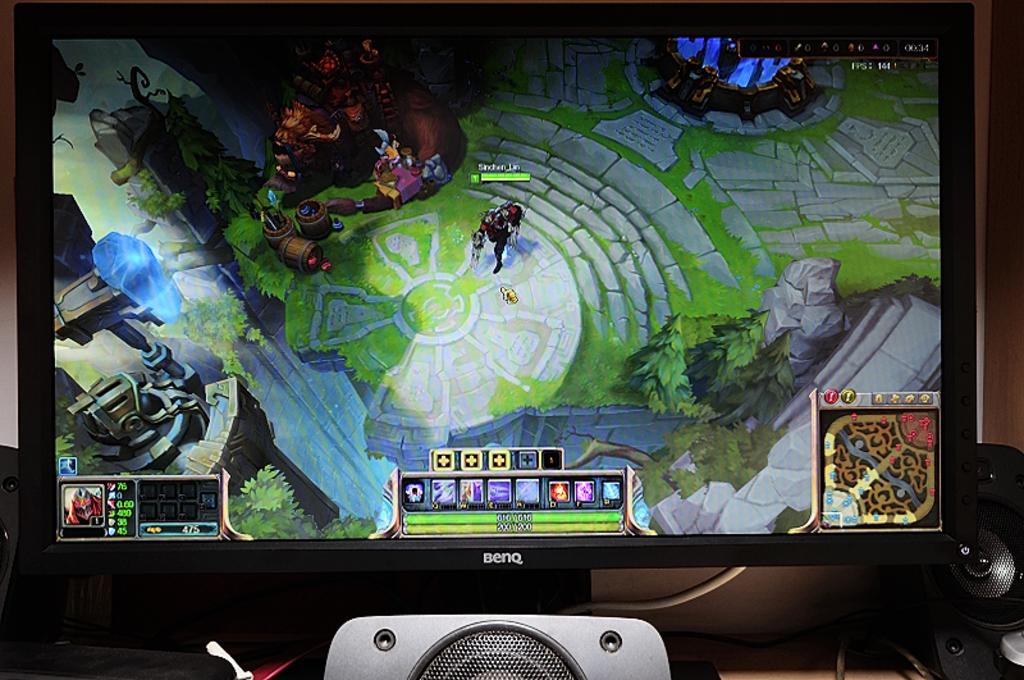<image>
Offer a succinct explanation of the picture presented. A TV labelled Benq has a video game playing on the screen. 